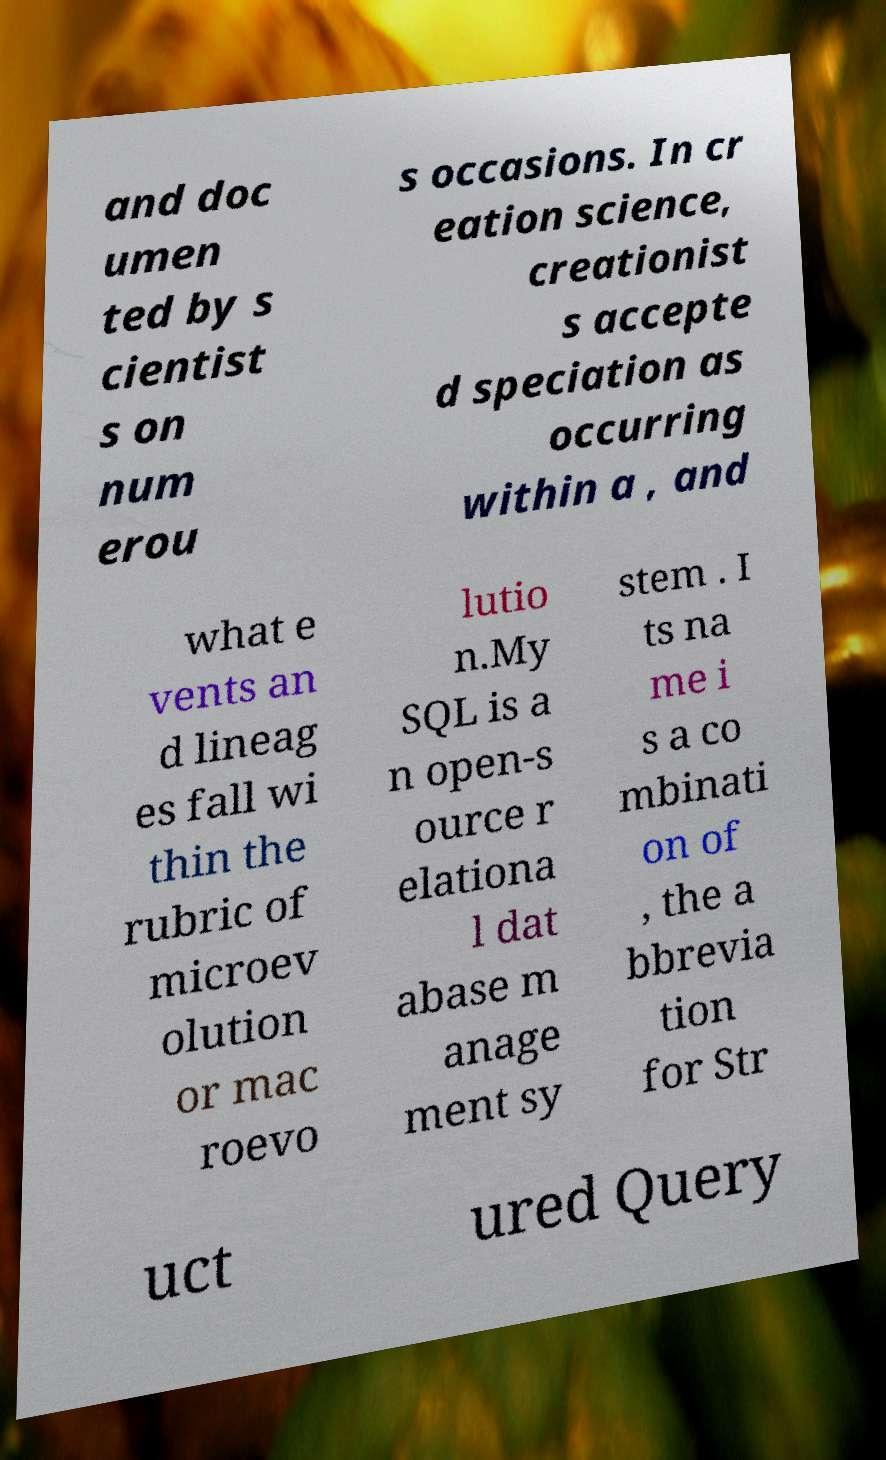Could you assist in decoding the text presented in this image and type it out clearly? and doc umen ted by s cientist s on num erou s occasions. In cr eation science, creationist s accepte d speciation as occurring within a , and what e vents an d lineag es fall wi thin the rubric of microev olution or mac roevo lutio n.My SQL is a n open-s ource r elationa l dat abase m anage ment sy stem . I ts na me i s a co mbinati on of , the a bbrevia tion for Str uct ured Query 